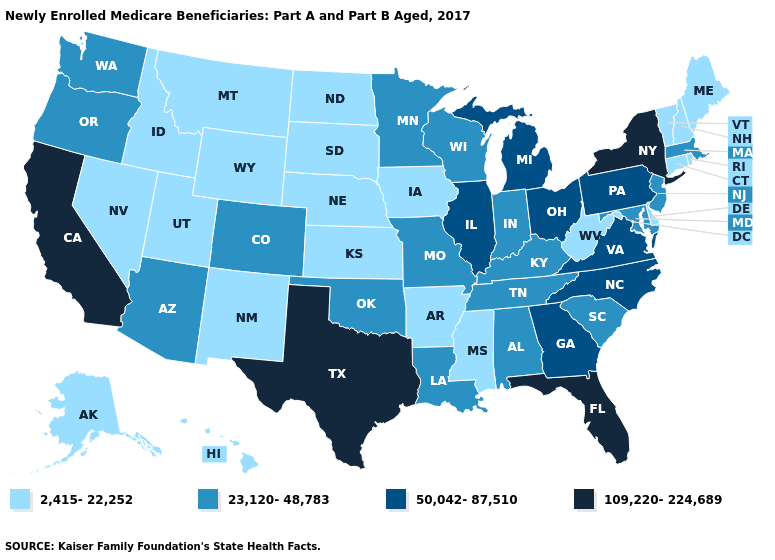What is the value of Arkansas?
Answer briefly. 2,415-22,252. What is the highest value in states that border Arkansas?
Short answer required. 109,220-224,689. Does the map have missing data?
Be succinct. No. Does Hawaii have the highest value in the West?
Write a very short answer. No. Does Connecticut have the same value as Oregon?
Answer briefly. No. Name the states that have a value in the range 109,220-224,689?
Keep it brief. California, Florida, New York, Texas. Does the map have missing data?
Concise answer only. No. What is the value of Michigan?
Answer briefly. 50,042-87,510. Does Tennessee have the lowest value in the South?
Answer briefly. No. What is the value of Virginia?
Give a very brief answer. 50,042-87,510. Name the states that have a value in the range 2,415-22,252?
Keep it brief. Alaska, Arkansas, Connecticut, Delaware, Hawaii, Idaho, Iowa, Kansas, Maine, Mississippi, Montana, Nebraska, Nevada, New Hampshire, New Mexico, North Dakota, Rhode Island, South Dakota, Utah, Vermont, West Virginia, Wyoming. Name the states that have a value in the range 109,220-224,689?
Quick response, please. California, Florida, New York, Texas. How many symbols are there in the legend?
Quick response, please. 4. How many symbols are there in the legend?
Write a very short answer. 4. Does the first symbol in the legend represent the smallest category?
Write a very short answer. Yes. 